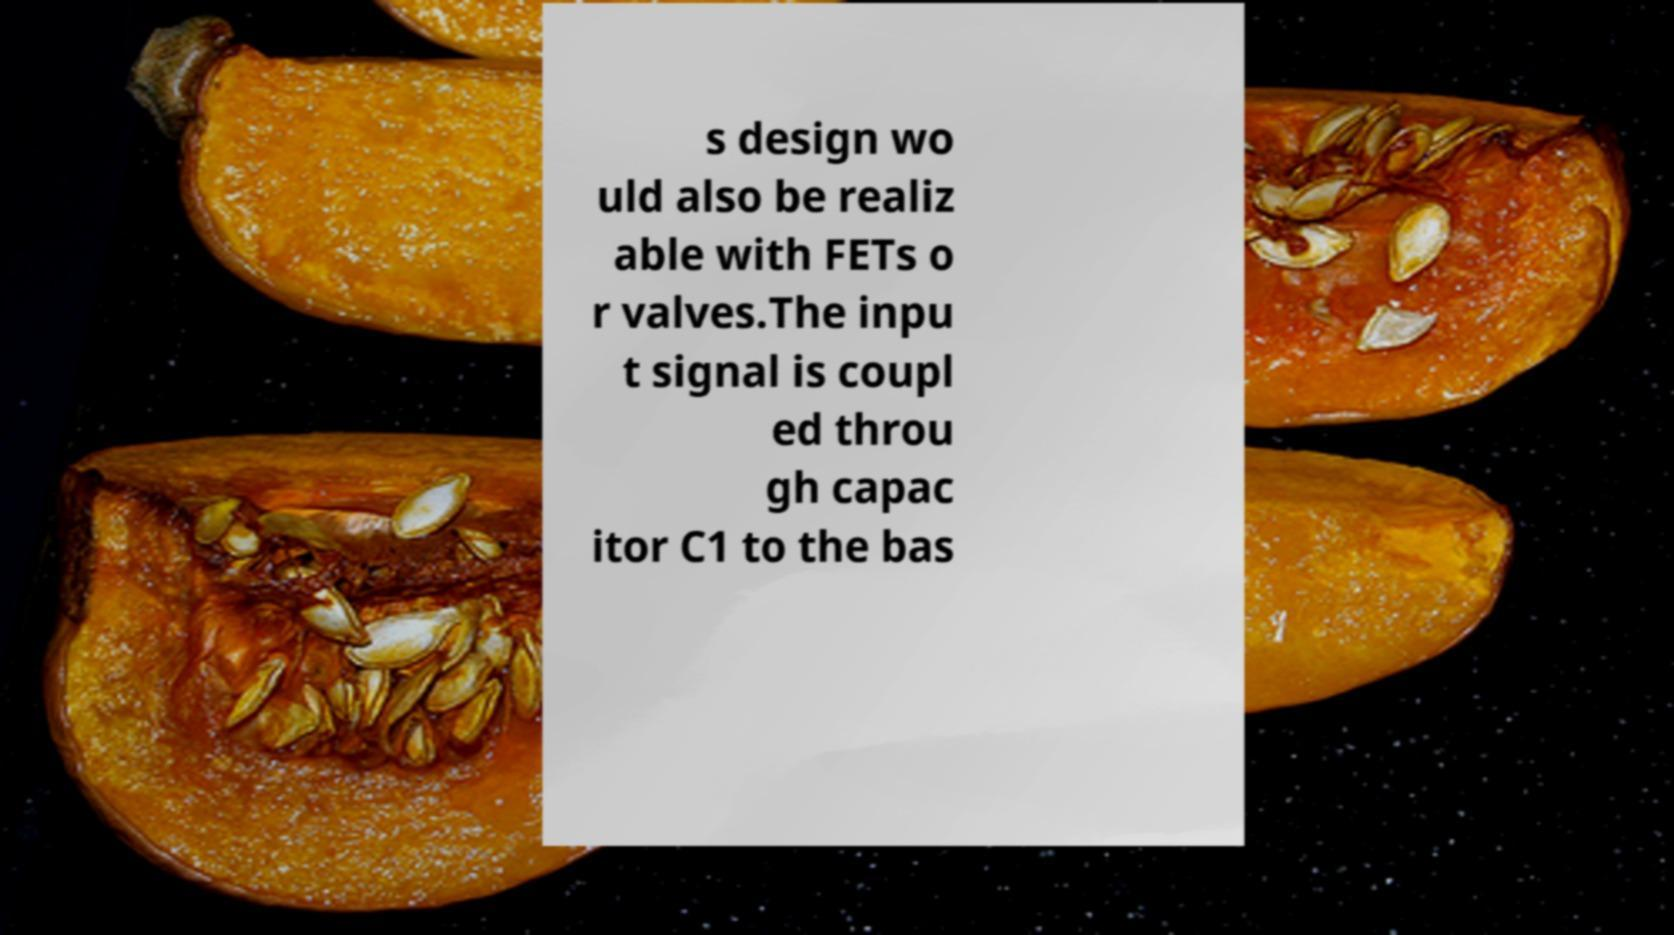Could you extract and type out the text from this image? s design wo uld also be realiz able with FETs o r valves.The inpu t signal is coupl ed throu gh capac itor C1 to the bas 